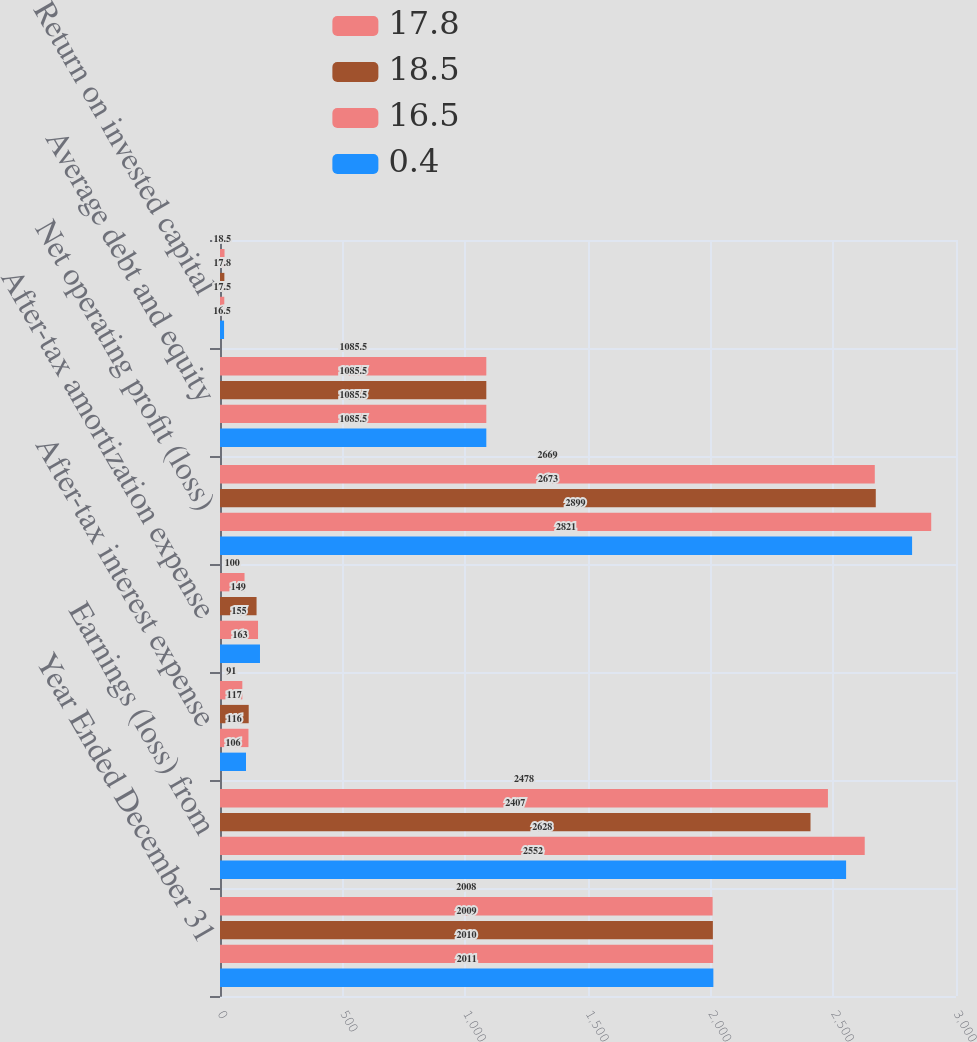Convert chart. <chart><loc_0><loc_0><loc_500><loc_500><stacked_bar_chart><ecel><fcel>Year Ended December 31<fcel>Earnings (loss) from<fcel>After-tax interest expense<fcel>After-tax amortization expense<fcel>Net operating profit (loss)<fcel>Average debt and equity<fcel>Return on invested capital<nl><fcel>17.8<fcel>2008<fcel>2478<fcel>91<fcel>100<fcel>2669<fcel>1085.5<fcel>18.5<nl><fcel>18.5<fcel>2009<fcel>2407<fcel>117<fcel>149<fcel>2673<fcel>1085.5<fcel>17.8<nl><fcel>16.5<fcel>2010<fcel>2628<fcel>116<fcel>155<fcel>2899<fcel>1085.5<fcel>17.5<nl><fcel>0.4<fcel>2011<fcel>2552<fcel>106<fcel>163<fcel>2821<fcel>1085.5<fcel>16.5<nl></chart> 